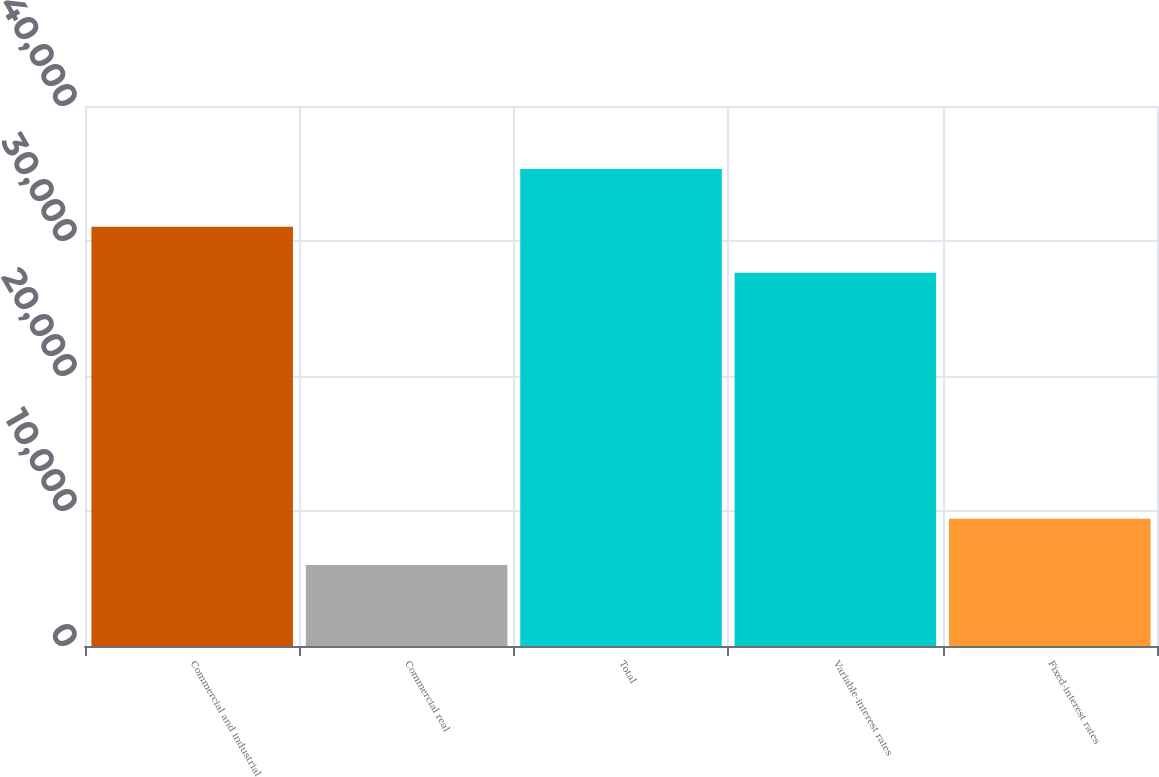Convert chart. <chart><loc_0><loc_0><loc_500><loc_500><bar_chart><fcel>Commercial and industrial<fcel>Commercial real<fcel>Total<fcel>Variable-interest rates<fcel>Fixed-interest rates<nl><fcel>31062.5<fcel>6008<fcel>35332<fcel>27651<fcel>9419.5<nl></chart> 